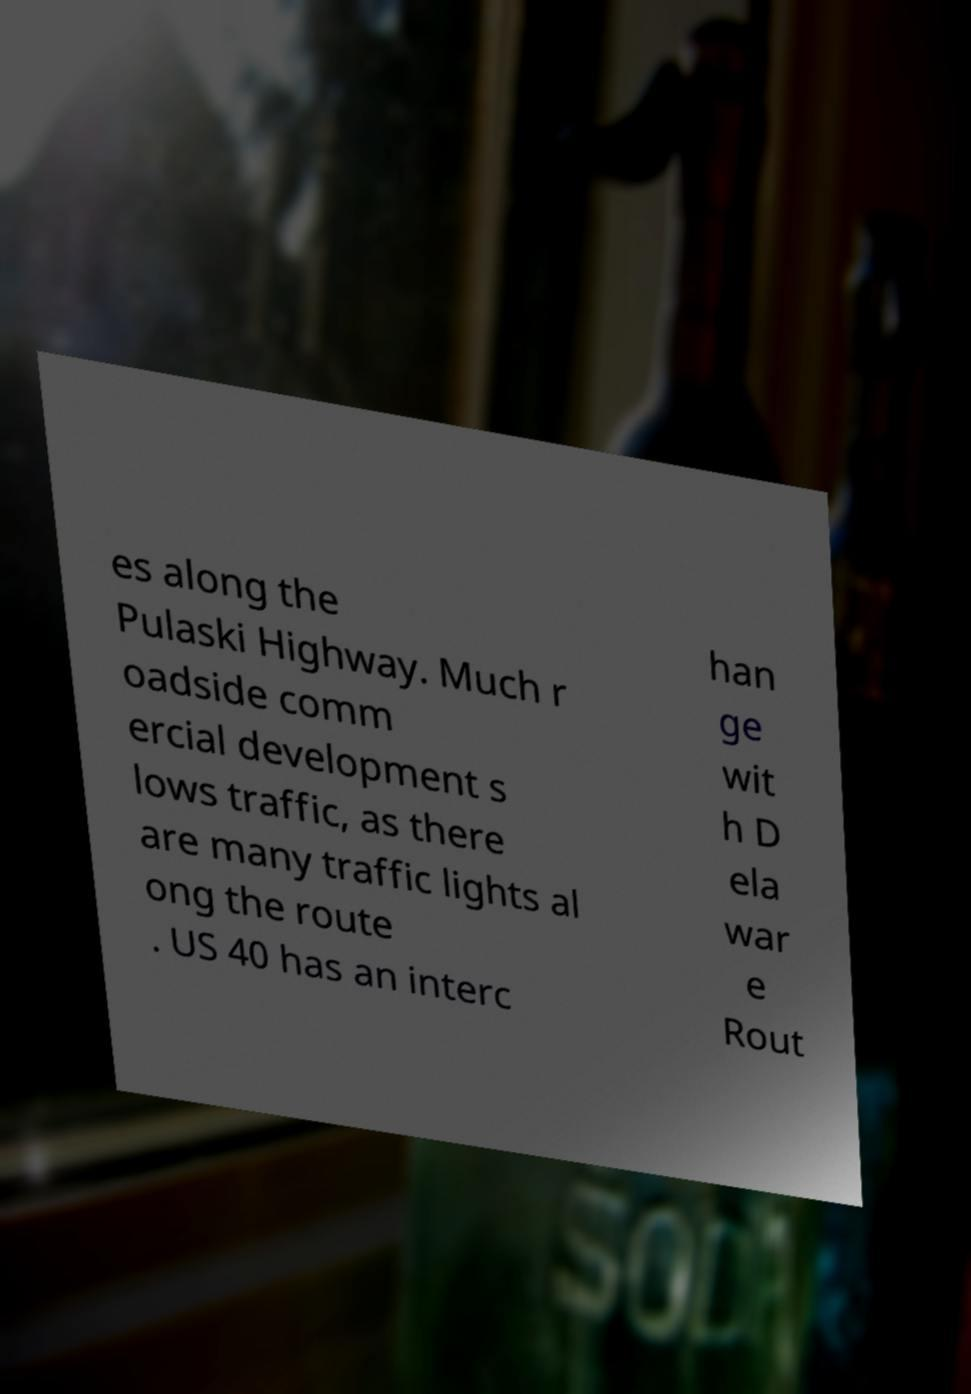Could you extract and type out the text from this image? es along the Pulaski Highway. Much r oadside comm ercial development s lows traffic, as there are many traffic lights al ong the route . US 40 has an interc han ge wit h D ela war e Rout 